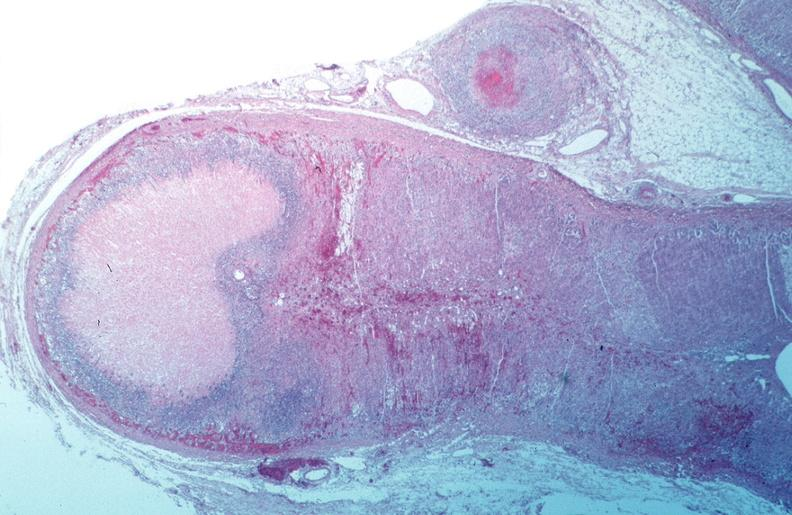does this image show vasculitis, polyarteritis nodosa?
Answer the question using a single word or phrase. Yes 